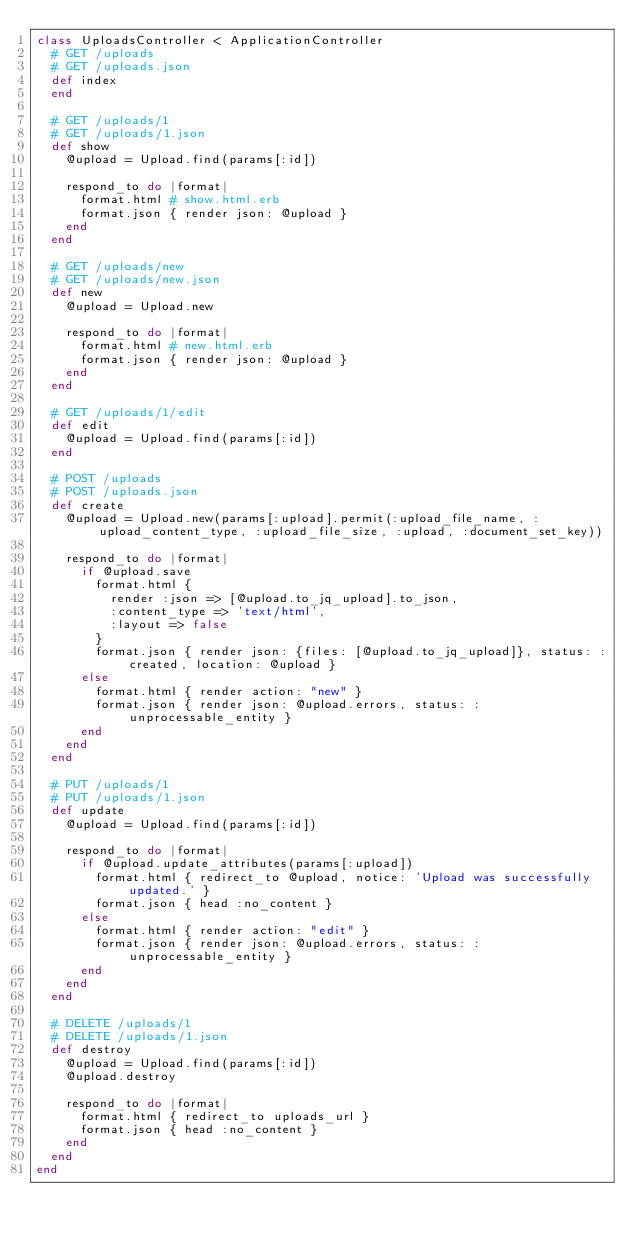Convert code to text. <code><loc_0><loc_0><loc_500><loc_500><_Ruby_>class UploadsController < ApplicationController
  # GET /uploads
  # GET /uploads.json
  def index
  end

  # GET /uploads/1
  # GET /uploads/1.json
  def show
    @upload = Upload.find(params[:id])

    respond_to do |format|
      format.html # show.html.erb
      format.json { render json: @upload }
    end
  end

  # GET /uploads/new
  # GET /uploads/new.json
  def new
    @upload = Upload.new

    respond_to do |format|
      format.html # new.html.erb
      format.json { render json: @upload }
    end
  end

  # GET /uploads/1/edit
  def edit
    @upload = Upload.find(params[:id])
  end

  # POST /uploads
  # POST /uploads.json
  def create
    @upload = Upload.new(params[:upload].permit(:upload_file_name, :upload_content_type, :upload_file_size, :upload, :document_set_key))

    respond_to do |format|
      if @upload.save
        format.html {
          render :json => [@upload.to_jq_upload].to_json,
          :content_type => 'text/html',
          :layout => false
        }
        format.json { render json: {files: [@upload.to_jq_upload]}, status: :created, location: @upload }
      else
        format.html { render action: "new" }
        format.json { render json: @upload.errors, status: :unprocessable_entity }
      end
    end
  end

  # PUT /uploads/1
  # PUT /uploads/1.json
  def update
    @upload = Upload.find(params[:id])

    respond_to do |format|
      if @upload.update_attributes(params[:upload])
        format.html { redirect_to @upload, notice: 'Upload was successfully updated.' }
        format.json { head :no_content }
      else
        format.html { render action: "edit" }
        format.json { render json: @upload.errors, status: :unprocessable_entity }
      end
    end
  end

  # DELETE /uploads/1
  # DELETE /uploads/1.json
  def destroy
    @upload = Upload.find(params[:id])
    @upload.destroy

    respond_to do |format|
      format.html { redirect_to uploads_url }
      format.json { head :no_content }
    end
  end
end
</code> 